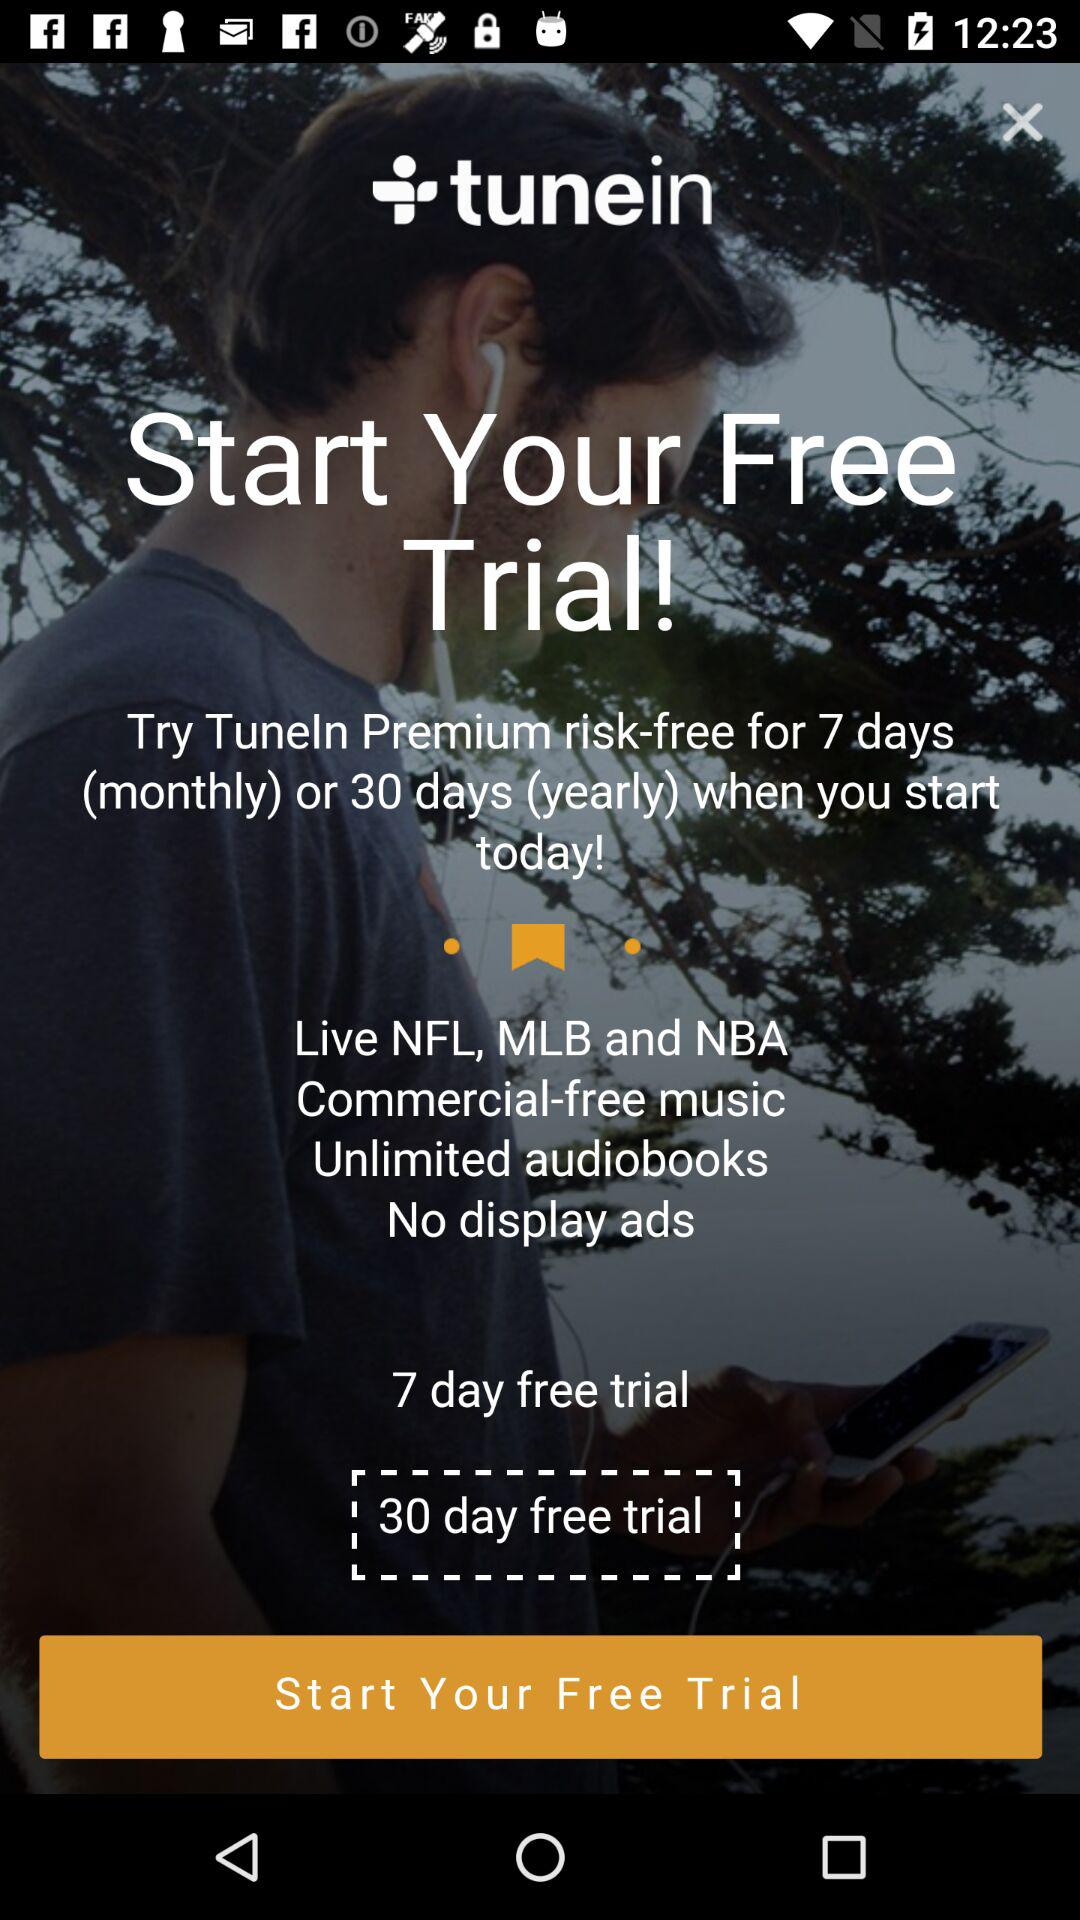What is the application name? The application name is "tunein". 